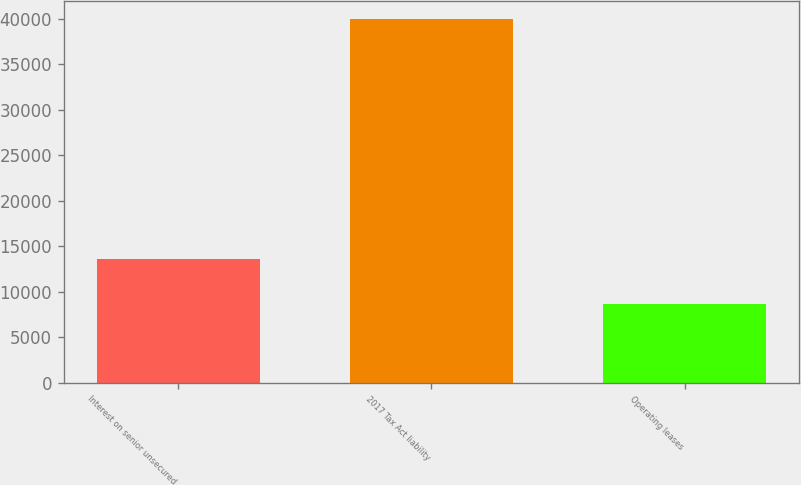Convert chart to OTSL. <chart><loc_0><loc_0><loc_500><loc_500><bar_chart><fcel>Interest on senior unsecured<fcel>2017 Tax Act liability<fcel>Operating leases<nl><fcel>13580<fcel>40000<fcel>8652<nl></chart> 